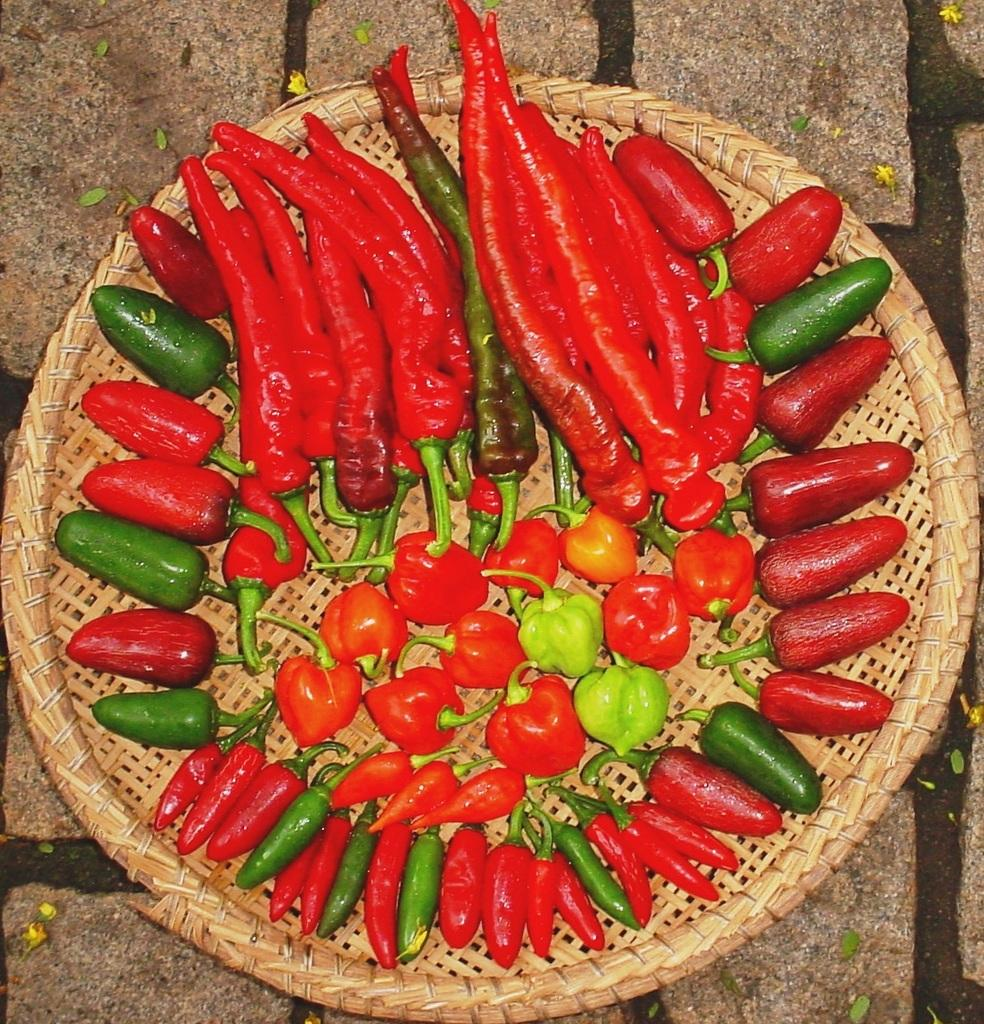What type of plate is in the image? There is a wooden plate in the image. Where is the plate located? The plate is placed on the ground. What types of food are on the plate? The plate contains red and green chilies, cherry tomatoes, and jalapeno. Is there a girl playing basketball on the wooden plate in the image? No, there is no girl playing basketball on the wooden plate in the image. The plate contains only food items, such as chilies and cherry tomatoes. 